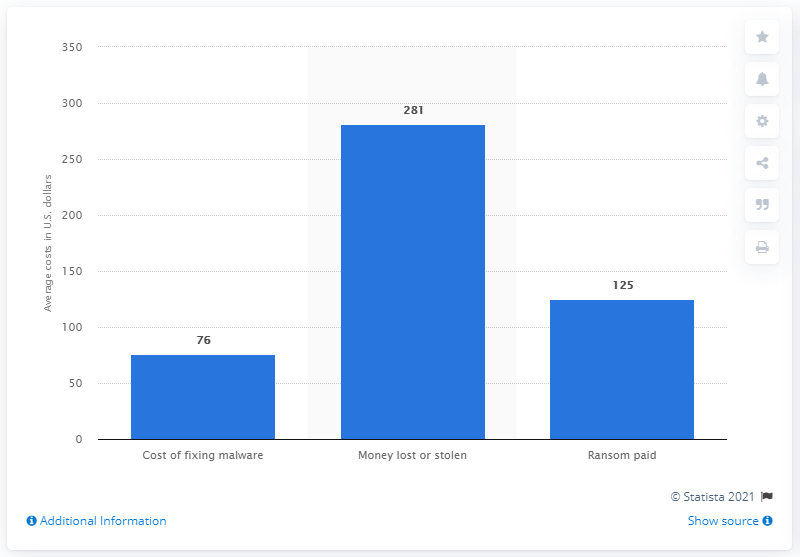Specify some key components in this picture. The global media average cost of fixing malware was $76 per device in the second half of 2017. 